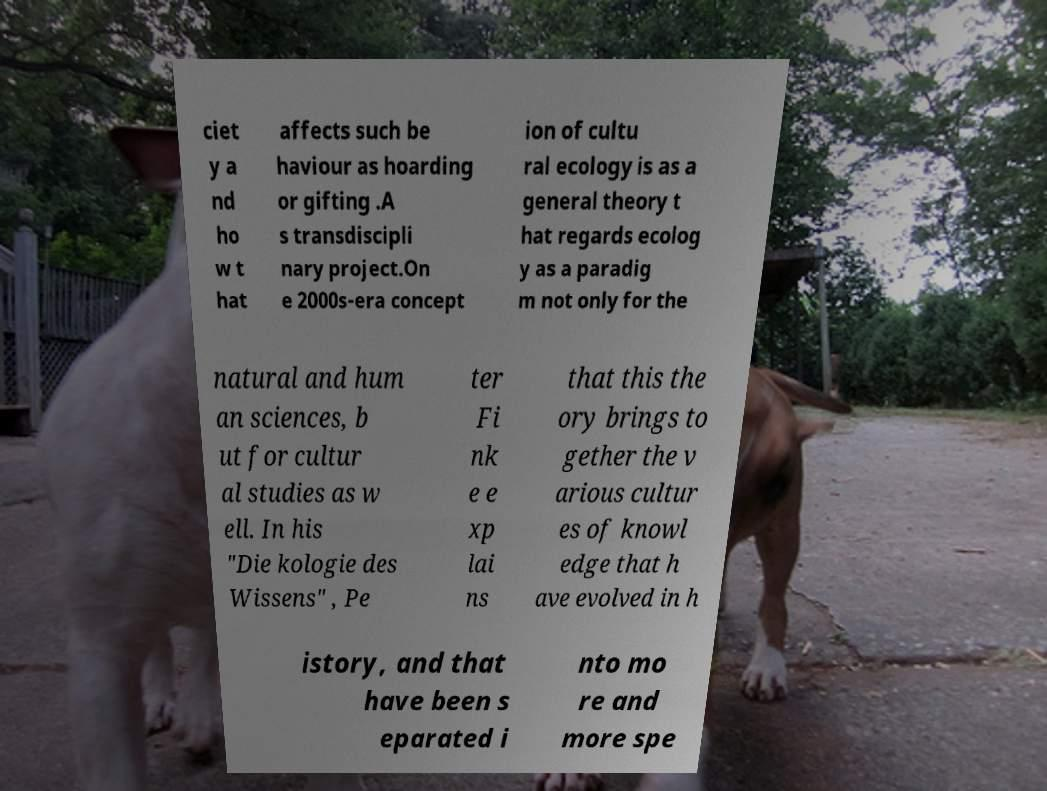For documentation purposes, I need the text within this image transcribed. Could you provide that? ciet y a nd ho w t hat affects such be haviour as hoarding or gifting .A s transdiscipli nary project.On e 2000s-era concept ion of cultu ral ecology is as a general theory t hat regards ecolog y as a paradig m not only for the natural and hum an sciences, b ut for cultur al studies as w ell. In his "Die kologie des Wissens" , Pe ter Fi nk e e xp lai ns that this the ory brings to gether the v arious cultur es of knowl edge that h ave evolved in h istory, and that have been s eparated i nto mo re and more spe 